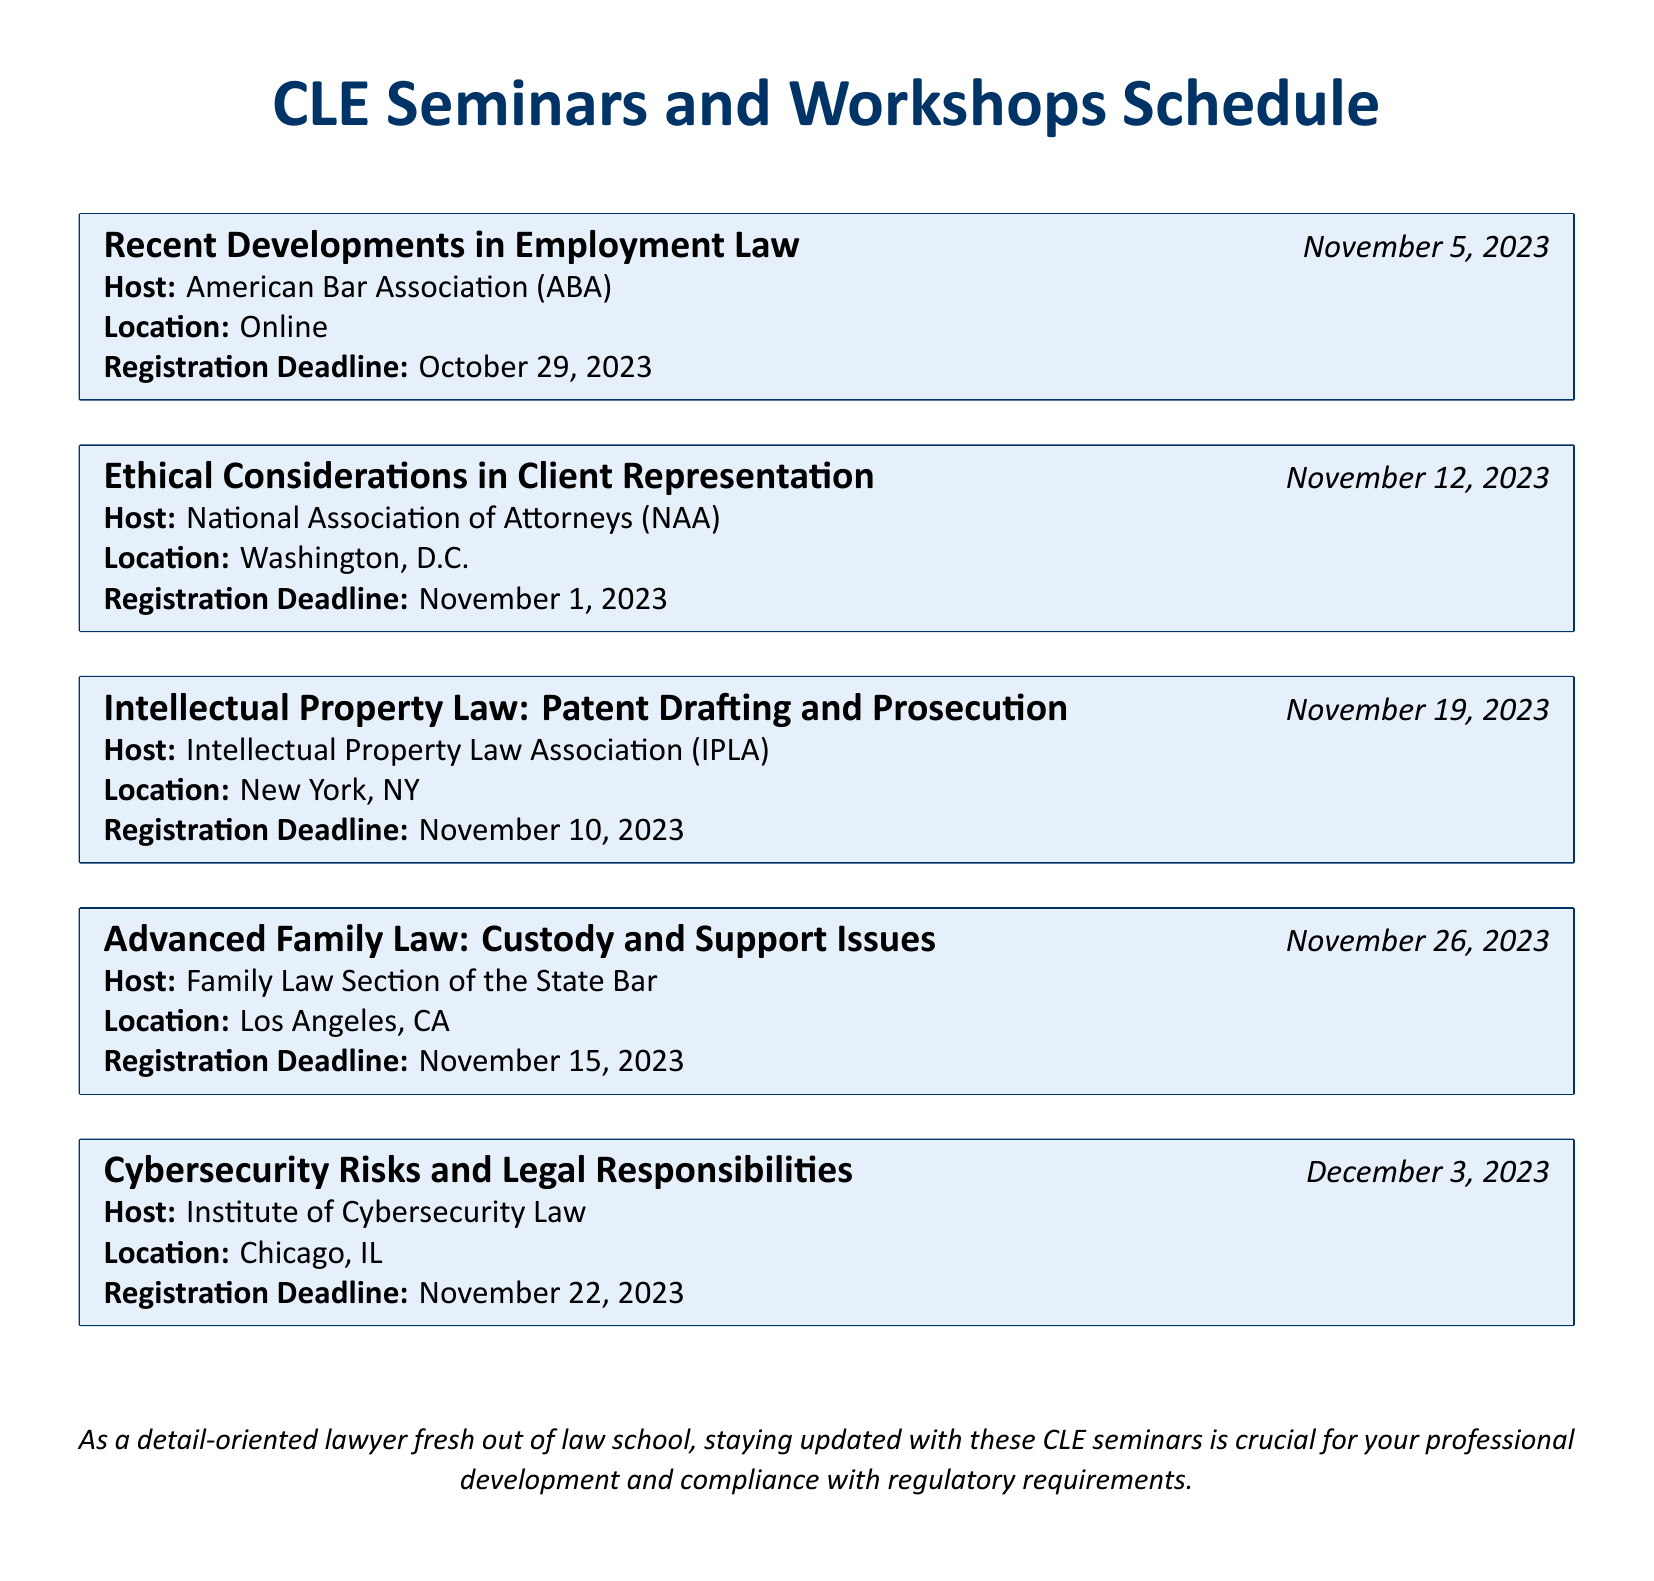What is the first seminar listed? The document lists the seminars in a chronological order, and the first seminar is on recent developments in employment law.
Answer: Recent Developments in Employment Law What is the date of the seminar on ethical considerations? The seminar on ethical considerations is scheduled for November 12, 2023, as indicated under its title.
Answer: November 12, 2023 Where is the seminar on intellectual property law being held? The location specified for the seminar on intellectual property law is New York, NY.
Answer: New York, NY What is the registration deadline for the advanced family law seminar? The document indicates the registration deadline for the advanced family law seminar is November 15, 2023.
Answer: November 15, 2023 How many seminars are scheduled for November? There are multiple seminars scheduled in November, specifically four as listed in the document.
Answer: Four Who is hosting the cybersecurity risks seminar? The document specifies that the seminar on cybersecurity risks is hosted by the Institute of Cybersecurity Law.
Answer: Institute of Cybersecurity Law Which seminar has the earliest registration deadline? By comparing the registration deadlines of the seminars listed, the earliest one is for the seminar on recent developments in employment law.
Answer: October 29, 2023 What location is associated with the ethical considerations seminar? The location for the ethical considerations seminar is specifically stated as Washington, D.C.
Answer: Washington, D.C What is the title of the last seminar listed? The last seminar in the document is focused on cybersecurity risks and legal responsibilities.
Answer: Cybersecurity Risks and Legal Responsibilities 